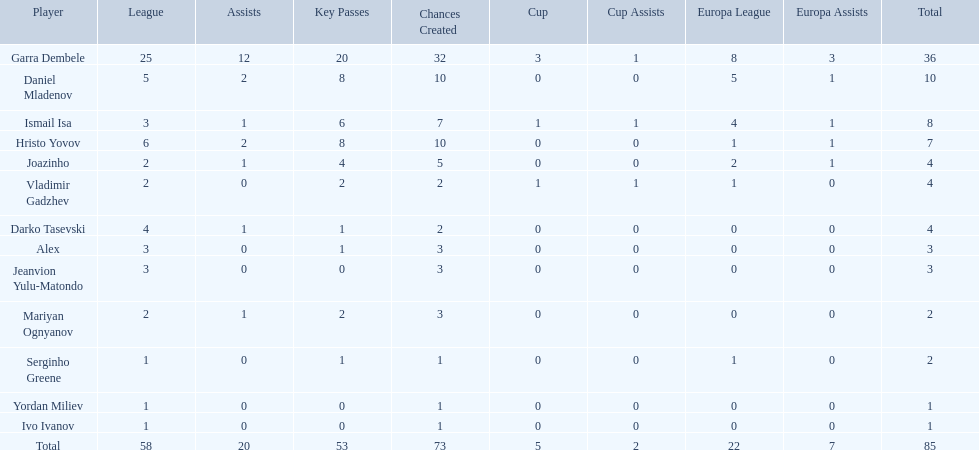How many goals did ismail isa score this season? 8. 